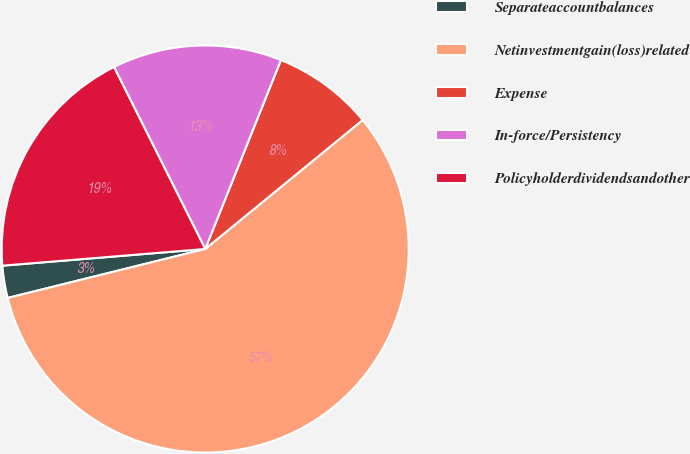Convert chart. <chart><loc_0><loc_0><loc_500><loc_500><pie_chart><fcel>Separateaccountbalances<fcel>Netinvestmentgain(loss)related<fcel>Expense<fcel>In-force/Persistency<fcel>Policyholderdividendsandother<nl><fcel>2.56%<fcel>57.05%<fcel>8.01%<fcel>13.46%<fcel>18.91%<nl></chart> 